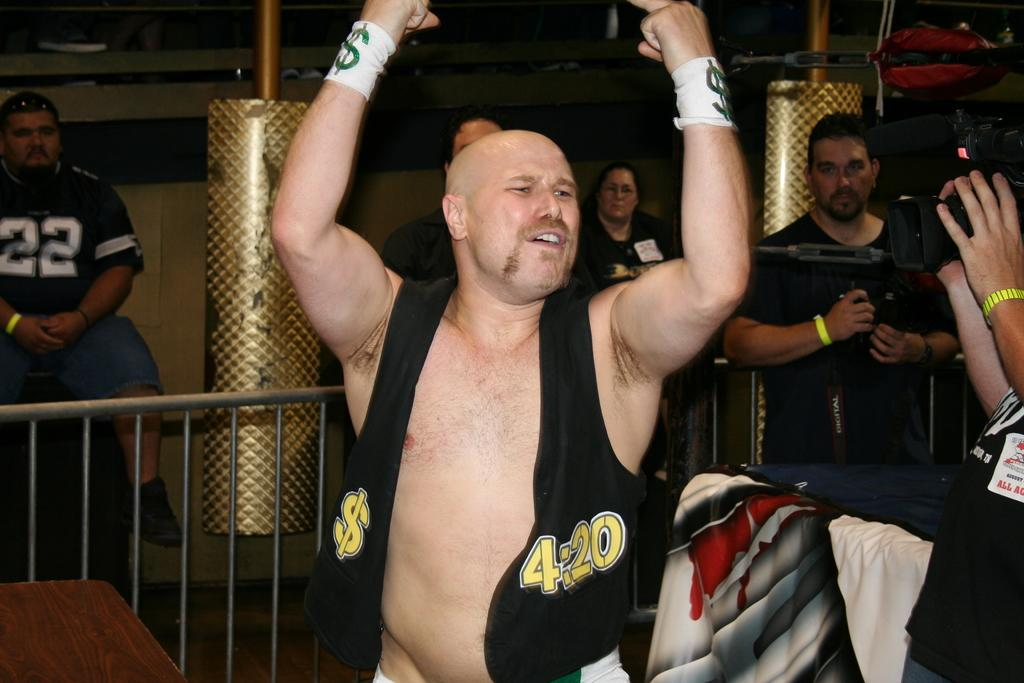Provide a one-sentence caption for the provided image. A man with a $ symbol and  4:20 written on his vest raises his hands in the air. 